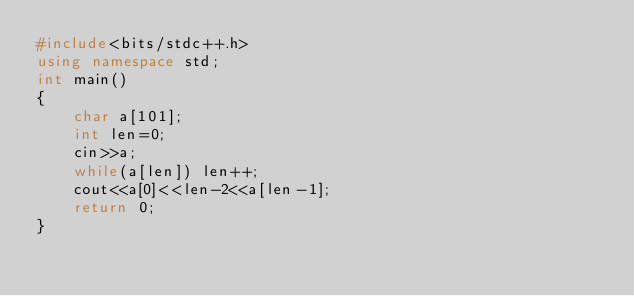Convert code to text. <code><loc_0><loc_0><loc_500><loc_500><_C++_>#include<bits/stdc++.h>
using namespace std;
int main()
{
    char a[101];
    int len=0;
    cin>>a;
    while(a[len]) len++;
    cout<<a[0]<<len-2<<a[len-1];
    return 0;
}</code> 